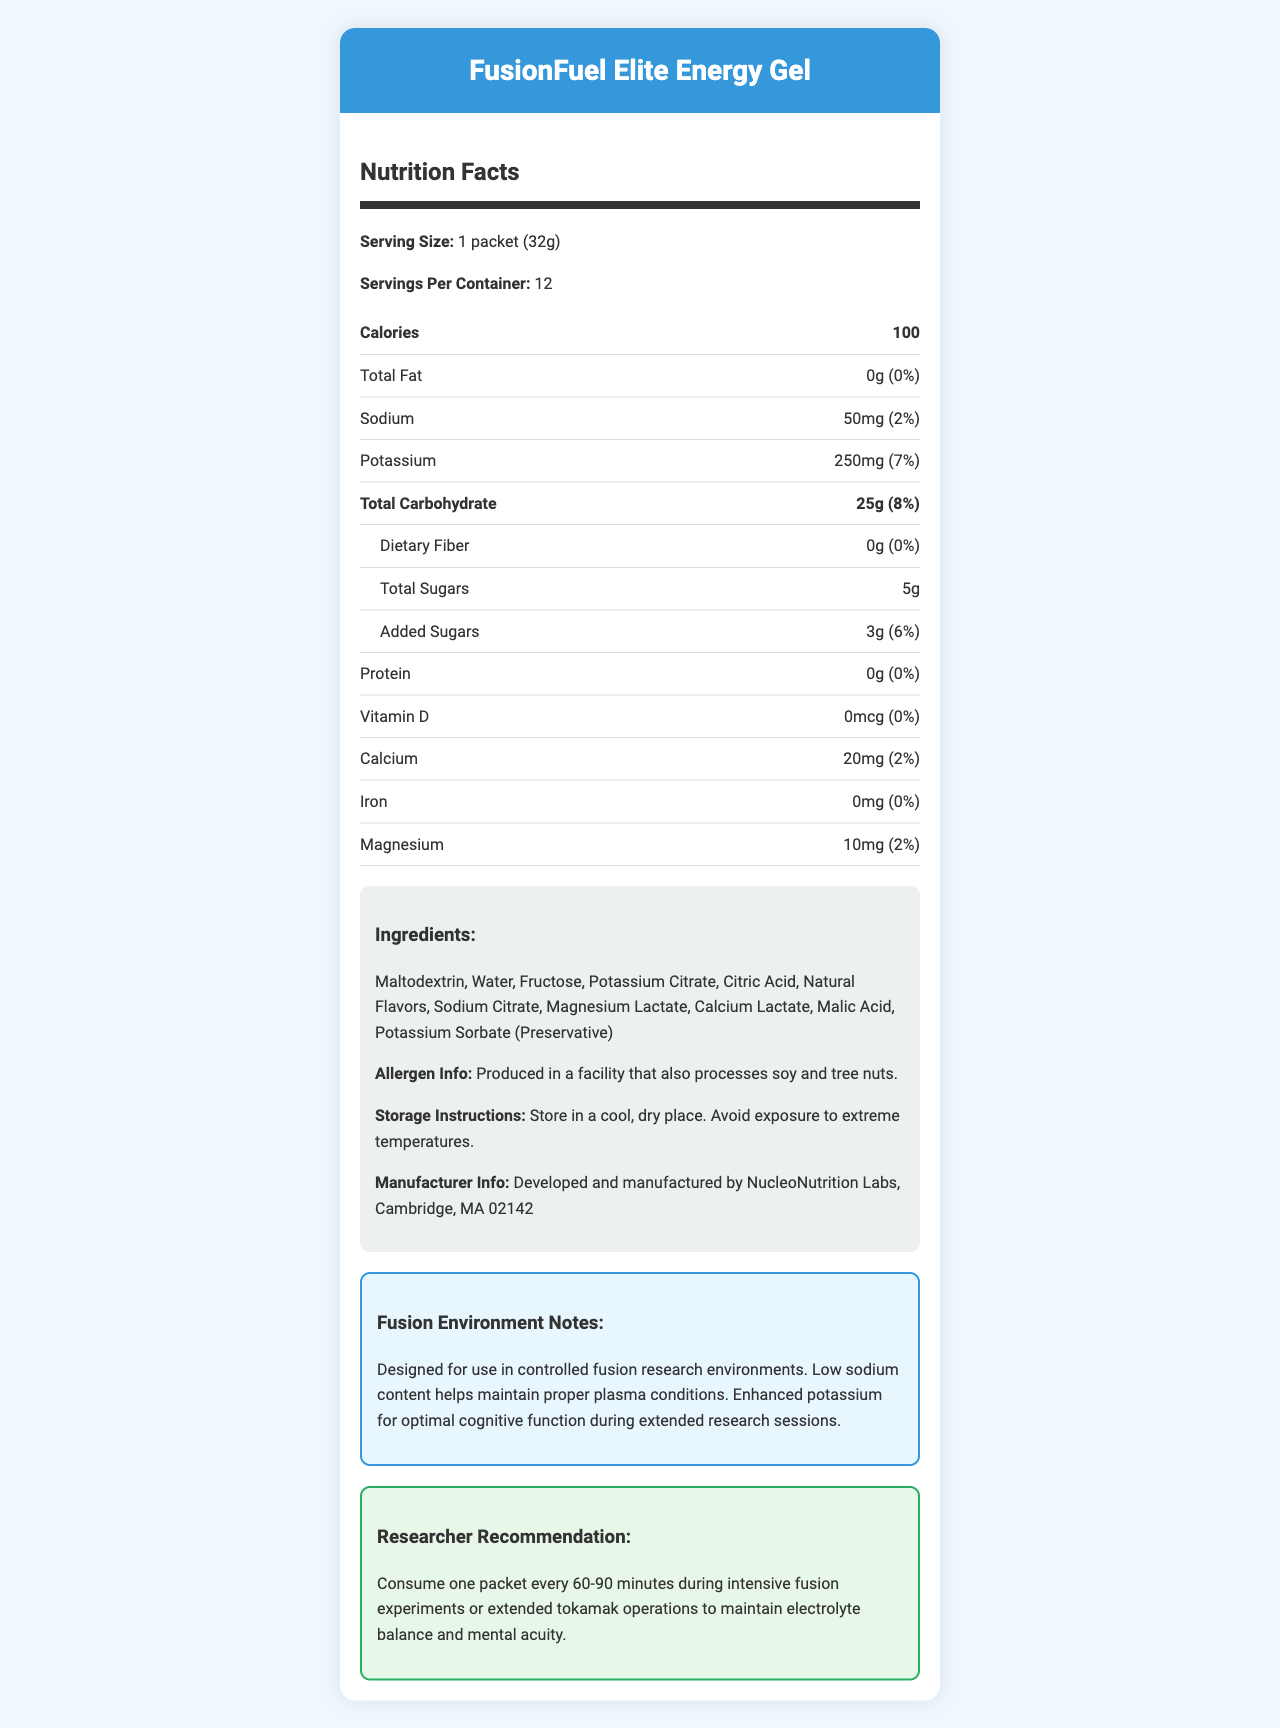what is the serving size of FusionFuel Elite Energy Gel? The serving size is explicitly listed as "1 packet (32g)" in the nutrition facts section of the document.
Answer: 1 packet (32g) how many servings are in one container of this energy gel? The document states "Servings Per Container: 12."
Answer: 12 how many calories are there per serving? The calories per serving are shown as 100 in the nutrition facts section.
Answer: 100 how much potassium does each serving contain? The amount of potassium per serving is listed as 250mg.
Answer: 250mg what percentage of the daily value of calcium does one serving provide? The calcium content per serving is noted to be 2% of the daily value.
Answer: 2% which of the following ingredients is not listed in the FusionFuel Elite Energy Gel? A. Maltodextrin B. Sucrose C. Fructose D. Citric Acid The listed ingredients include Maltodextrin, Fructose, and Citric Acid but not Sucrose.
Answer: B. Sucrose what is the total amount of carbs in one serving? The total carbohydrate per serving is listed as 25g.
Answer: 25g how much added sugar is in the energy gel per serving? The document shows that there are 3g of added sugars per serving.
Answer: 3g which nutrient has the highest daily value percentage in one serving? A. Potassium B. Sodium C. Calcium D. Magnesium Potassium has a daily value of 7%, which is the highest among the listed nutrients.
Answer: A. Potassium is this energy gel produced in a nut-free facility? The allergen info indicates that it is produced in a facility that also processes soy and tree nuts.
Answer: No summarize the purpose of FusionFuel Elite Energy Gel. The document explains that the gel is formulated to support electrolyte balance and mental function in controlled fusion research environments, with specific benefits mentioned regarding its sodium and potassium content.
Answer: It is a low-sodium, high-potassium energy gel designed to maintain electrolyte balance and cognitive function during extended research sessions in fusion environments. what is the recommended consumption frequency during intensive fusion experiments? The researcher recommendation advises consuming one packet every 60-90 minutes during intensive experiments.
Answer: One packet every 60-90 minutes does this product contain any dietary fiber? The dietary fiber content is listed as 0g with 0% daily value.
Answer: No what is the manufacturer's location? The manufacturer info details that the gel is developed and manufactured by NucleoNutrition Labs, Cambridge, MA 02142.
Answer: Cambridge, MA 02142 what is the protein content per serving? The document lists the protein content as 0g per serving.
Answer: 0g is there any information about the environmental sustainability of FusionFuel Elite Energy Gel? The document does not provide any details relating to the environmental sustainability of the product.
Answer: Not enough information 